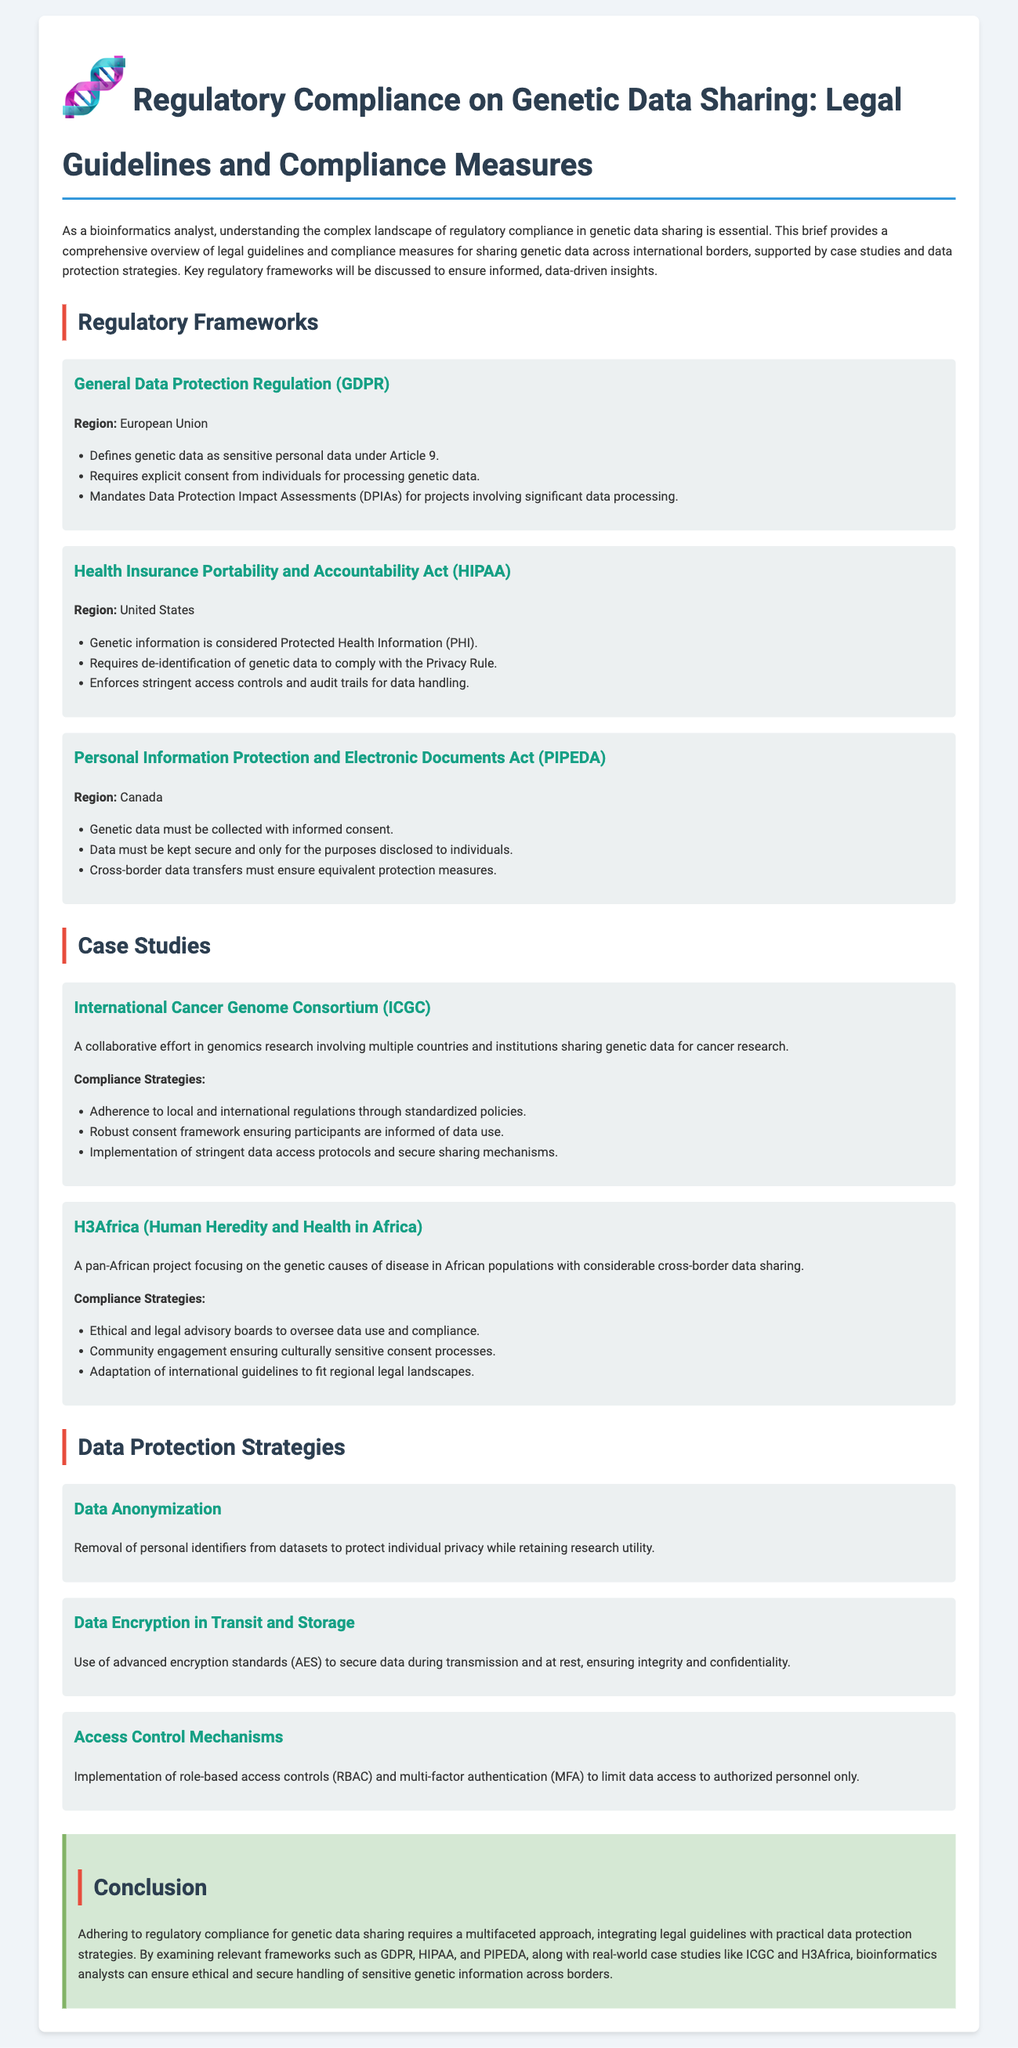What is the main focus of the document? The document provides an overview of legal guidelines and compliance measures for sharing genetic data across international borders.
Answer: Legal guidelines and compliance measures for sharing genetic data Which regulation defines genetic data as sensitive personal data? GDPR, mentioned in the regulatory frameworks section, specifically states this under Article 9.
Answer: GDPR What is required before processing genetic data under HIPAA? HIPAA mandates de-identification of genetic data to comply with the Privacy Rule, which requires protection measures before processing.
Answer: De-identification What project is associated with international cancer genomics research? The document mentions the International Cancer Genome Consortium (ICGC) as a relevant case study in the context of compliance in genetic data sharing.
Answer: International Cancer Genome Consortium (ICGC) What data protection strategy involves removing personal identifiers? The document states that data anonymization is the strategy for protecting individual privacy by removing identifiers.
Answer: Data anonymization Which country’s regulation requires equivalent protection measures for cross-border data transfers? Canada's Personal Information Protection and Electronic Documents Act (PIPEDA) specifies that equivalent protection measures are needed for cross-border data transfers.
Answer: Canada What type of boards oversee data use in the H3Africa project? The document highlights that ethical and legal advisory boards supervise data use and compliance in the H3Africa project.
Answer: Ethical and legal advisory boards How many compliance strategies are listed for the ICGC case study? Three compliance strategies are outlined in the case study of the International Cancer Genome Consortium.
Answer: Three What encryption standard is mentioned for securing data? The document specifies the use of advanced encryption standards (AES) for securing data during transmission and storage.
Answer: Advanced encryption standards (AES) 